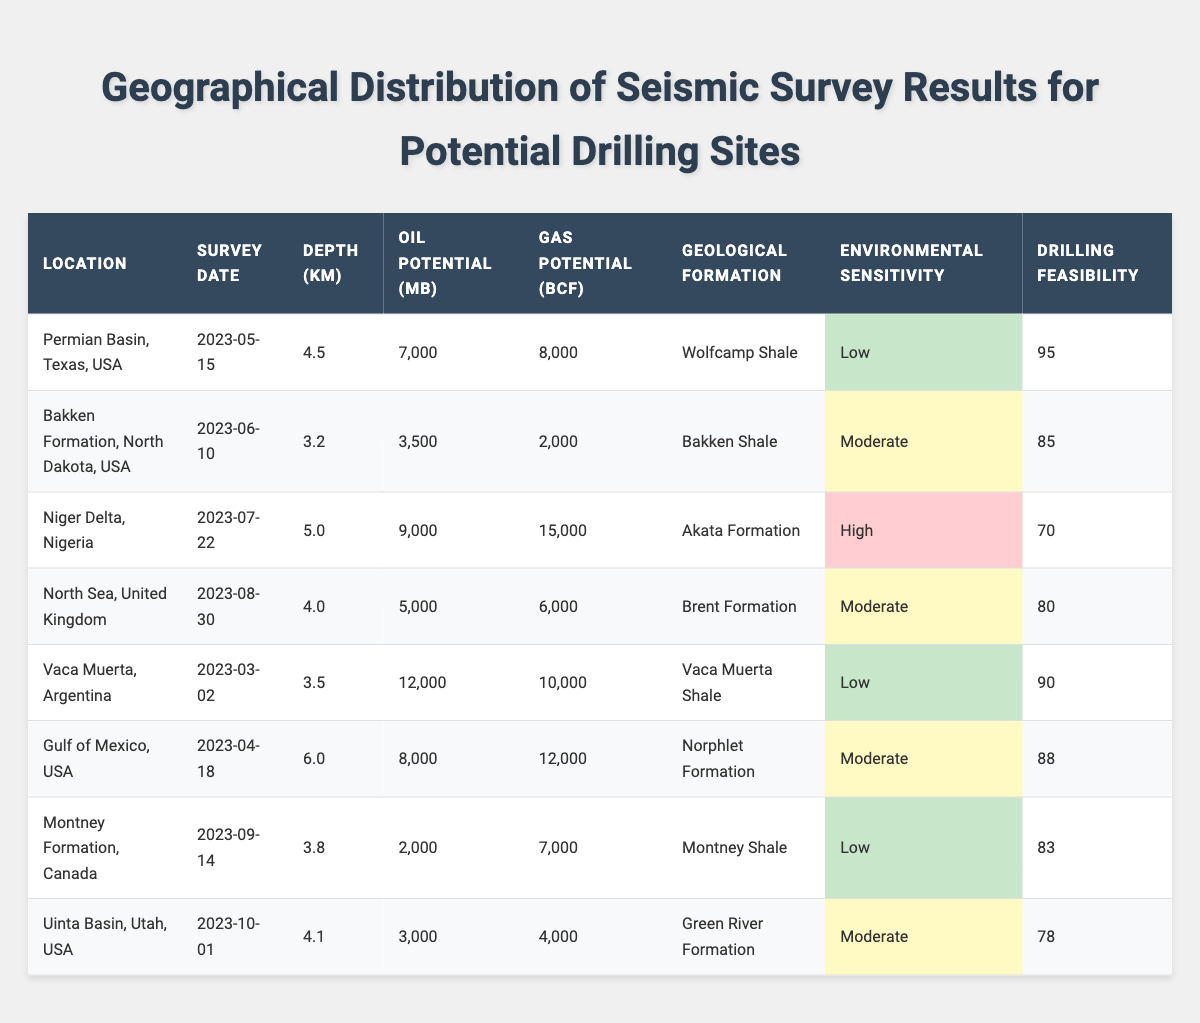What is the oil potential in the Vaca Muerta location? The table shows that under the "Oil Potential (Million Barrels)" column, the value for Vaca Muerta, Argentina is 12,000 million barrels.
Answer: 12,000 million barrels Which location has the highest drilling feasibility score? By inspecting the "Drilling Feasibility Score" column, the Permian Basin has the highest score of 95.
Answer: Permian Basin, Texas, USA What is the average gas potential across all locations? First, I sum the gas potential values: (8000 + 2000 + 15000 + 6000 + 10000 + 12000 + 7000 + 4000) =  80000 billion cubic feet. There are 8 data points, so the average gas potential is 80000/8 = 10000.
Answer: 10,000 billion cubic feet Is the environmental sensitivity index in Niger Delta high? Checking the "Environmental Sensitivity Index" for Niger Delta, Nigeria shows that it is classified as "High." Thus, the statement is true.
Answer: Yes What are the geological formations of locations with a low environmental sensitivity index? I check the "Environmental Sensitivity Index" and find that the Permian Basin, Vaca Muerta, and Montney Formation have a low index. Their formations are Wolfcamp Shale, Vaca Muerta Shale, and Montney Shale respectively.
Answer: Wolfcamp Shale, Vaca Muerta Shale, Montney Shale Which location has the deepest seismic survey, and what is the depth? The "Survey Depth (km)" for the Gulf of Mexico location is 6.0 km, which is higher than the others, making it the deepest.
Answer: Gulf of Mexico, 6.0 km How does the oil potential of Niger Delta compare to the Bakken Formation? The oil potential for Niger Delta is 9,000 million barrels, while for Bakken Formation it is 3,500 million barrels. Therefore, Niger Delta has higher oil potential by a difference of (9000 - 3500) = 5500 million barrels.
Answer: Niger Delta has 5,500 million barrels more oil potential than Bakken Formation What percentage of locations have a drilling feasibility score greater than 85? There are 3 locations with scores greater than 85 (Permian Basin, Vaca Muerta, and Gulf of Mexico) out of a total of 8 locations. Thus, the percentage is (3/8) * 100 = 37.5%.
Answer: 37.5% Which is the only location with high environmental sensitivity, and what is its drilling feasibility score? The only location marked as "High" in the "Environmental Sensitivity Index" is the Niger Delta, Nigeria. Its drilling feasibility score is 70.
Answer: Niger Delta, 70 What is the relationship between survey depth and gas potential for the locations? To analyze the relationship, I notice that the gas potential tends to vary inversely with increased survey depth, suggesting that deeper surveys like in the Gulf of Mexico (6.0 km) see higher gas potential, while shallower depths like Bakken (3.2 km) have lower gas potential.
Answer: Generally, deeper depths correlate with higher gas potential What geological formations are located in regions with moderate environmental sensitivity? The North Sea and Gulf of Mexico have moderate sensitivity. Their geological formations are Brent Formation and Norphlet Formation, respectively.
Answer: Brent Formation, Norphlet Formation 